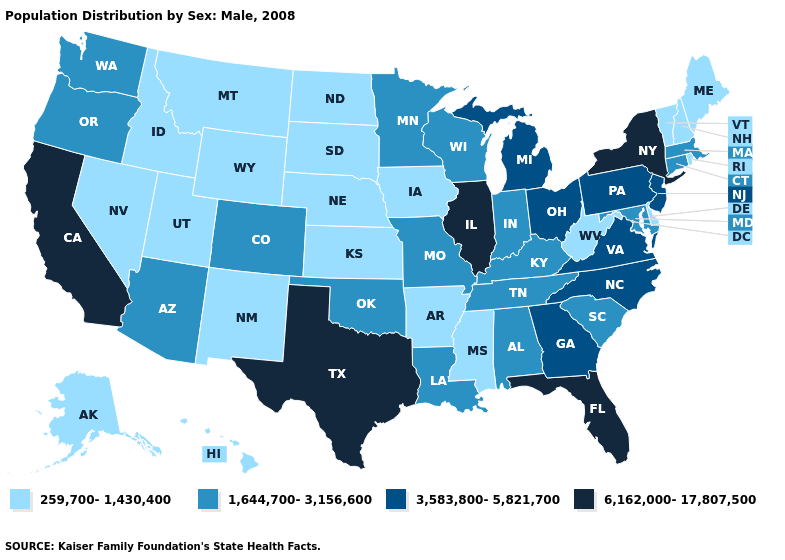Name the states that have a value in the range 1,644,700-3,156,600?
Quick response, please. Alabama, Arizona, Colorado, Connecticut, Indiana, Kentucky, Louisiana, Maryland, Massachusetts, Minnesota, Missouri, Oklahoma, Oregon, South Carolina, Tennessee, Washington, Wisconsin. What is the value of North Carolina?
Answer briefly. 3,583,800-5,821,700. Does New Jersey have the lowest value in the Northeast?
Answer briefly. No. Name the states that have a value in the range 6,162,000-17,807,500?
Quick response, please. California, Florida, Illinois, New York, Texas. What is the lowest value in the MidWest?
Give a very brief answer. 259,700-1,430,400. Does the map have missing data?
Short answer required. No. Among the states that border Idaho , which have the highest value?
Be succinct. Oregon, Washington. What is the highest value in states that border Maryland?
Give a very brief answer. 3,583,800-5,821,700. Among the states that border Virginia , which have the lowest value?
Give a very brief answer. West Virginia. Name the states that have a value in the range 259,700-1,430,400?
Write a very short answer. Alaska, Arkansas, Delaware, Hawaii, Idaho, Iowa, Kansas, Maine, Mississippi, Montana, Nebraska, Nevada, New Hampshire, New Mexico, North Dakota, Rhode Island, South Dakota, Utah, Vermont, West Virginia, Wyoming. Name the states that have a value in the range 1,644,700-3,156,600?
Quick response, please. Alabama, Arizona, Colorado, Connecticut, Indiana, Kentucky, Louisiana, Maryland, Massachusetts, Minnesota, Missouri, Oklahoma, Oregon, South Carolina, Tennessee, Washington, Wisconsin. Does Michigan have the lowest value in the USA?
Short answer required. No. Name the states that have a value in the range 3,583,800-5,821,700?
Answer briefly. Georgia, Michigan, New Jersey, North Carolina, Ohio, Pennsylvania, Virginia. Does Rhode Island have the lowest value in the USA?
Short answer required. Yes. 